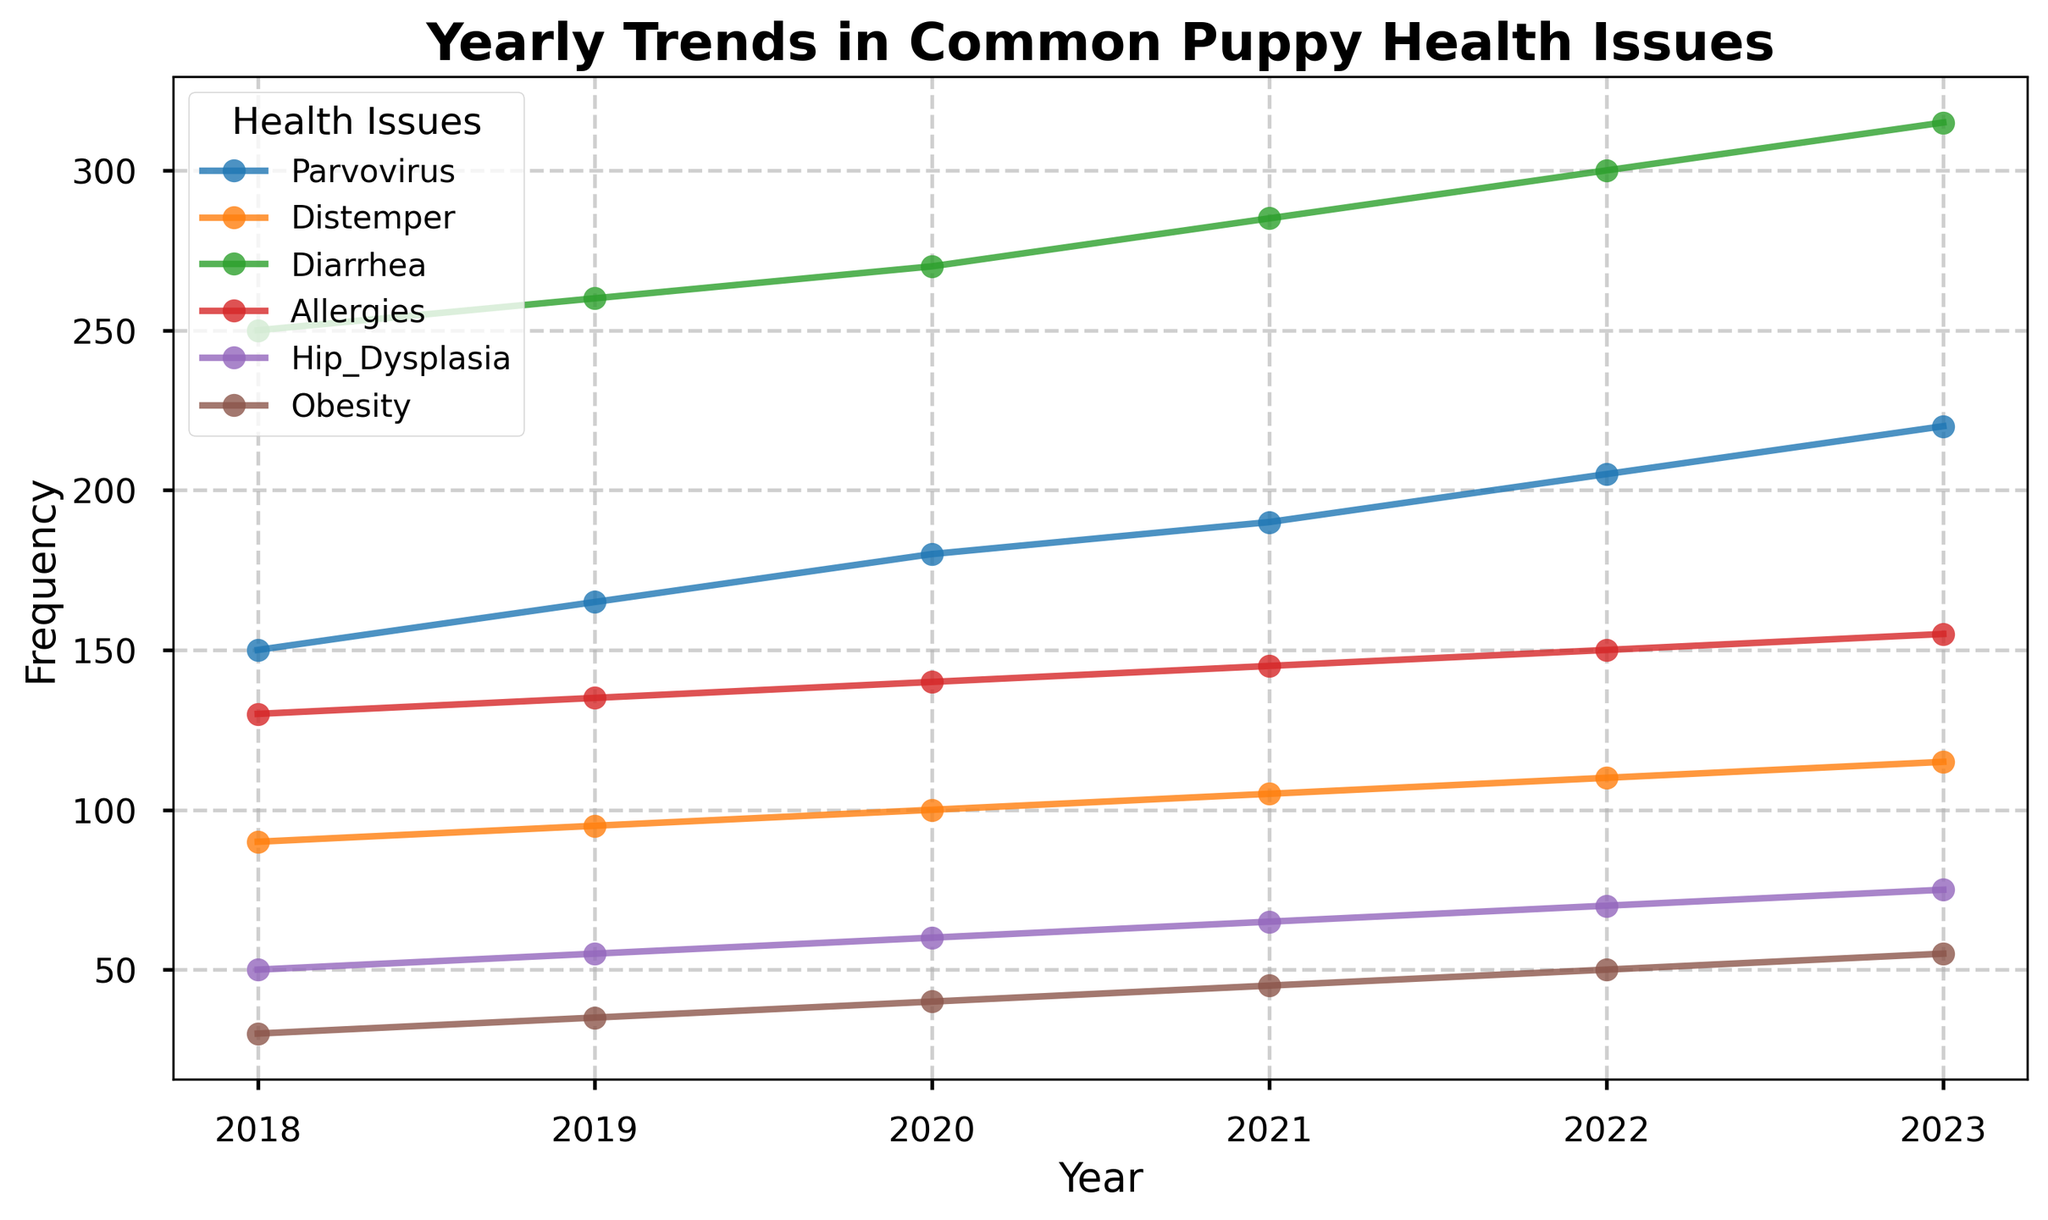Which health issue showed the highest increase in frequency from 2018 to 2023? To determine the highest increase, subtract the frequency in 2018 from the frequency in 2023 for each health issue, and then compare the differences. 
- Parvovirus: 220 - 150 = 70
- Distemper: 115 - 90 = 25
- Diarrhea: 315 - 250 = 65
- Allergies: 155 - 130 = 25
- Hip Dysplasia: 75 - 50 = 25
- Obesity: 55 - 30 = 25
The health issue with the highest increase is Parvovirus with an increase of 70.
Answer: Parvovirus How did the frequency of Allergies change from 2019 to 2022? Subtract the frequency in 2019 from the frequency in 2022.
- Allergies in 2022: 150
- Allergies in 2019: 135
150 - 135 = 15 
The frequency of Allergies increased by 15 from 2019 to 2022.
Answer: Increased by 15 Which health issue had the least frequency in 2023, and what was its value? Examine the frequencies for all health issues in 2023 and identify the smallest value.
- Parvovirus: 220
- Distemper: 115
- Diarrhea: 315
- Allergies: 155
- Hip Dysplasia: 75
- Obesity: 55
The health issue with the least frequency is Obesity at 55.
Answer: Obesity, 55 Comparing Diarrhea and Hip Dysplasia, which had a higher frequency in 2021, and by how much? Compare the values for Diarrhea and Hip Dysplasia in 2021.
- Diarrhea in 2021: 285
- Hip Dysplasia in 2021: 65
285 - 65 = 220
Diarrhea had a higher frequency by 220.
Answer: Diarrhea, by 220 What is the average yearly frequency of Distemper from 2018 to 2023? Add the yearly frequencies of Distemper from 2018 to 2023 and then divide by the number of years (6).
(90 + 95 + 100 + 105 + 110 + 115)/6 = 615/6 = 102.5 
The average yearly frequency of Distemper is 102.5.
Answer: 102.5 What was the trend for the frequency of Obesity from 2018 to 2023? Observe the frequency values for Obesity each year and describe the direction of the trend over time.
- Obesity: 30 (2018), 35 (2019), 40 (2020), 45 (2021), 50 (2022), 55 (2023)
Obesity shows a steadily increasing trend.
Answer: Increasing 